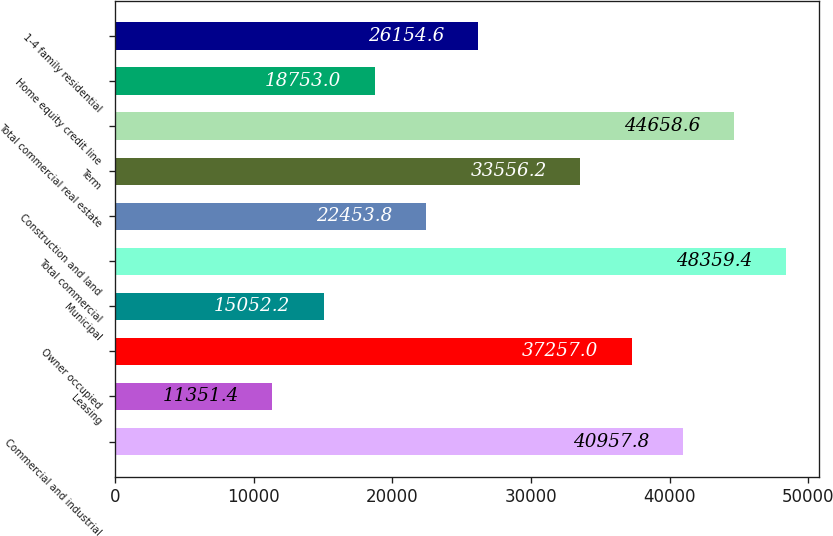Convert chart to OTSL. <chart><loc_0><loc_0><loc_500><loc_500><bar_chart><fcel>Commercial and industrial<fcel>Leasing<fcel>Owner occupied<fcel>Municipal<fcel>Total commercial<fcel>Construction and land<fcel>Term<fcel>Total commercial real estate<fcel>Home equity credit line<fcel>1-4 family residential<nl><fcel>40957.8<fcel>11351.4<fcel>37257<fcel>15052.2<fcel>48359.4<fcel>22453.8<fcel>33556.2<fcel>44658.6<fcel>18753<fcel>26154.6<nl></chart> 